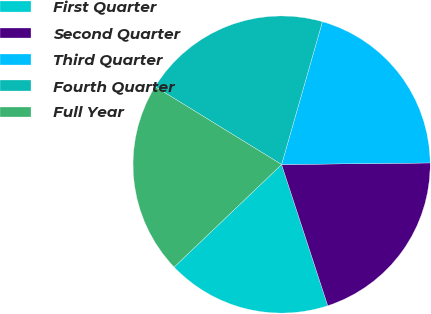Convert chart. <chart><loc_0><loc_0><loc_500><loc_500><pie_chart><fcel>First Quarter<fcel>Second Quarter<fcel>Third Quarter<fcel>Fourth Quarter<fcel>Full Year<nl><fcel>17.9%<fcel>20.14%<fcel>20.4%<fcel>20.65%<fcel>20.91%<nl></chart> 